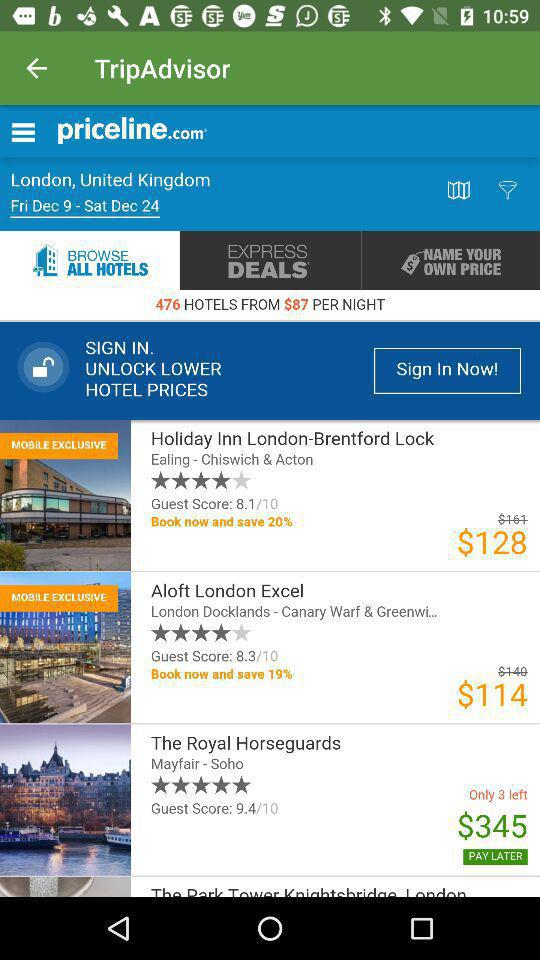What is the given location? The given location is London, United Kingdom. 